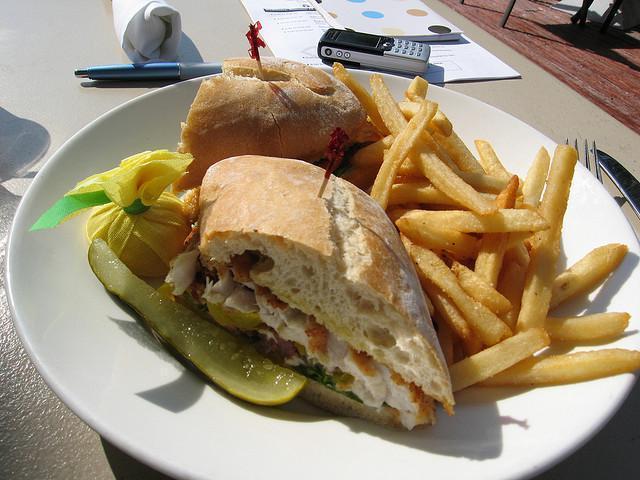How many layers is this sandwich?
Give a very brief answer. 1. How many sandwiches can be seen?
Give a very brief answer. 2. How many brown cows are there on the beach?
Give a very brief answer. 0. 